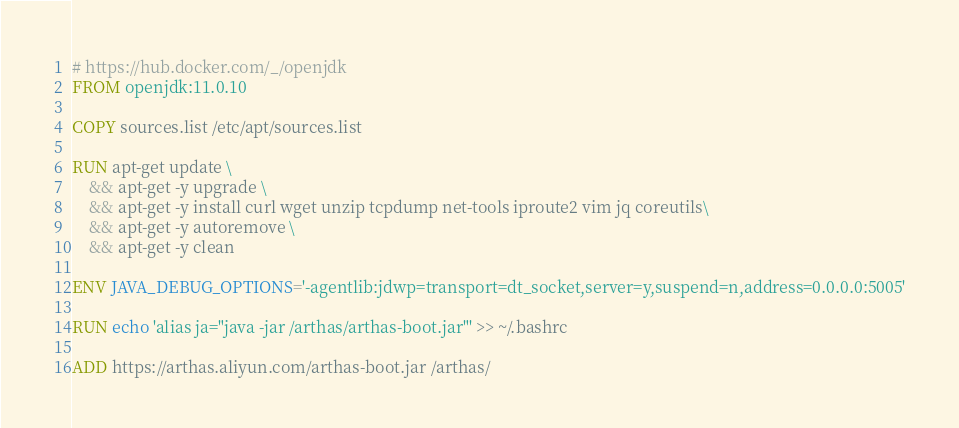<code> <loc_0><loc_0><loc_500><loc_500><_Dockerfile_># https://hub.docker.com/_/openjdk
FROM openjdk:11.0.10

COPY sources.list /etc/apt/sources.list

RUN apt-get update \
    && apt-get -y upgrade \
    && apt-get -y install curl wget unzip tcpdump net-tools iproute2 vim jq coreutils\
    && apt-get -y autoremove \
    && apt-get -y clean

ENV JAVA_DEBUG_OPTIONS='-agentlib:jdwp=transport=dt_socket,server=y,suspend=n,address=0.0.0.0:5005'

RUN echo 'alias ja="java -jar /arthas/arthas-boot.jar"' >> ~/.bashrc

ADD https://arthas.aliyun.com/arthas-boot.jar /arthas/
</code> 